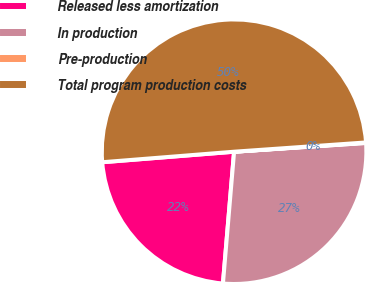Convert chart. <chart><loc_0><loc_0><loc_500><loc_500><pie_chart><fcel>Released less amortization<fcel>In production<fcel>Pre-production<fcel>Total program production costs<nl><fcel>22.39%<fcel>27.4%<fcel>0.06%<fcel>50.15%<nl></chart> 